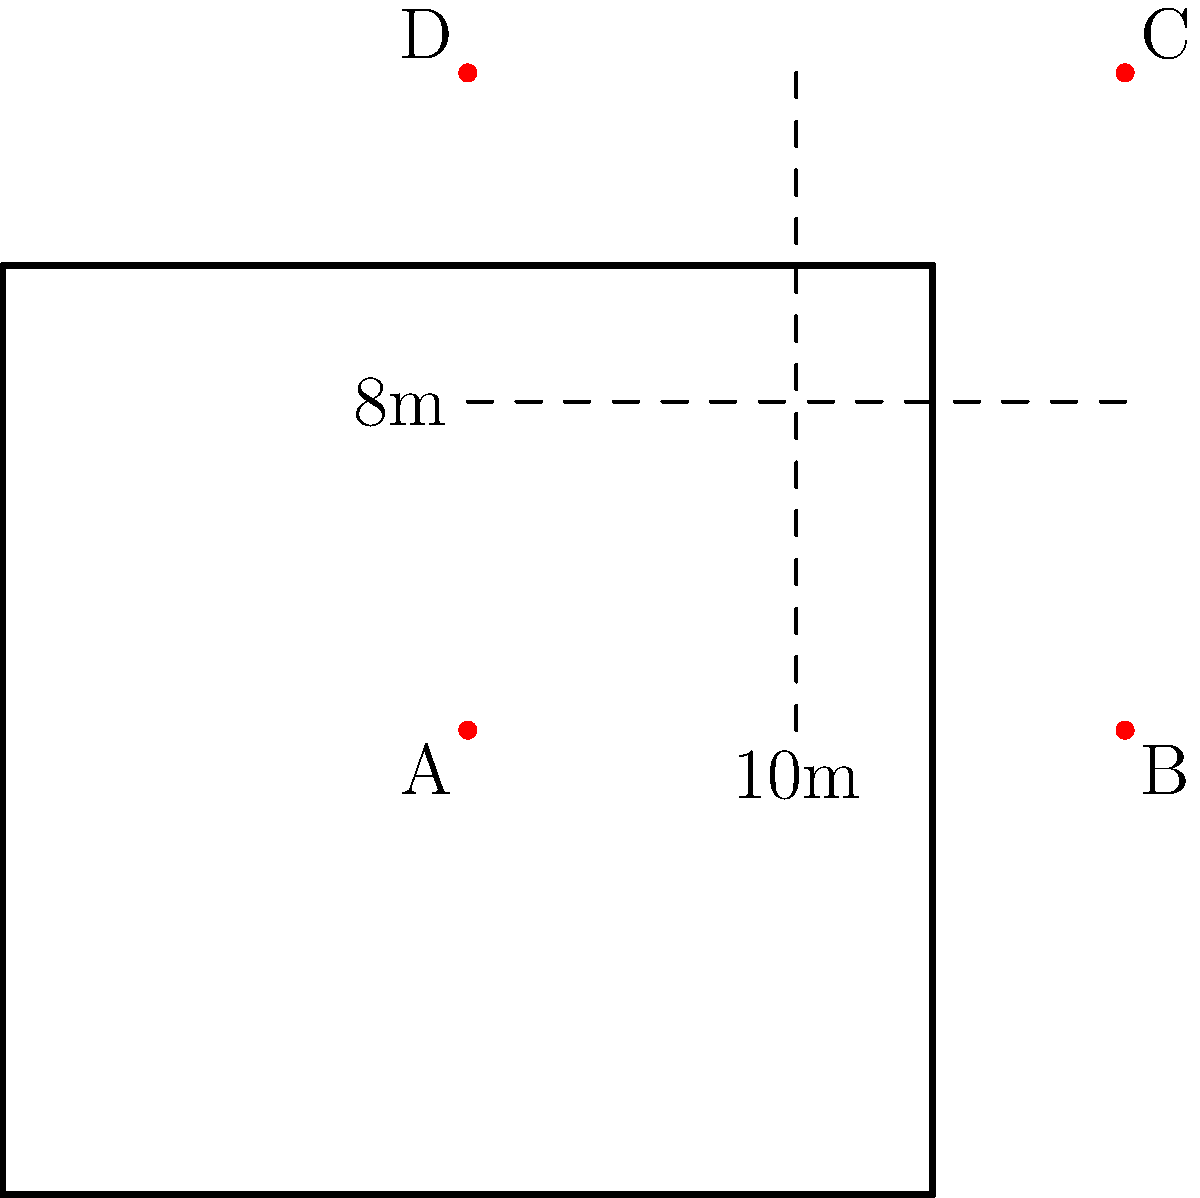In a rectangular courtroom with dimensions 10m x 8m, you need to arrange 12 jury members in a semicircle facing the judge's bench. If each juror requires a minimum of 0.75m of space along the arc, what is the maximum radius of the semicircle that can fit within the courtroom while maintaining at least 1m distance from the walls? To solve this problem, we'll follow these steps:

1. Calculate the required arc length for 12 jurors:
   $12 \times 0.75\text{m} = 9\text{m}$

2. The formula for arc length is $L = r\theta$, where $r$ is the radius and $\theta$ is the angle in radians. For a semicircle, $\theta = \pi$.
   $9 = r\pi$

3. Solve for $r$:
   $r = \frac{9}{\pi} \approx 2.86\text{m}$

4. Check if this radius fits within the courtroom constraints:
   - The semicircle must fit within the 8m width, leaving 1m on each side:
     $2r \leq 8 - 2 = 6\text{m}$
   - The radius must not exceed the 10m length minus 1m:
     $r \leq 10 - 1 = 9\text{m}$

5. The calculated radius (2.86m) satisfies both constraints:
   $2 \times 2.86 = 5.72\text{m} < 6\text{m}$
   $2.86\text{m} < 9\text{m}$

Therefore, the maximum radius that satisfies all conditions is approximately 2.86m.
Answer: $2.86\text{m}$ 